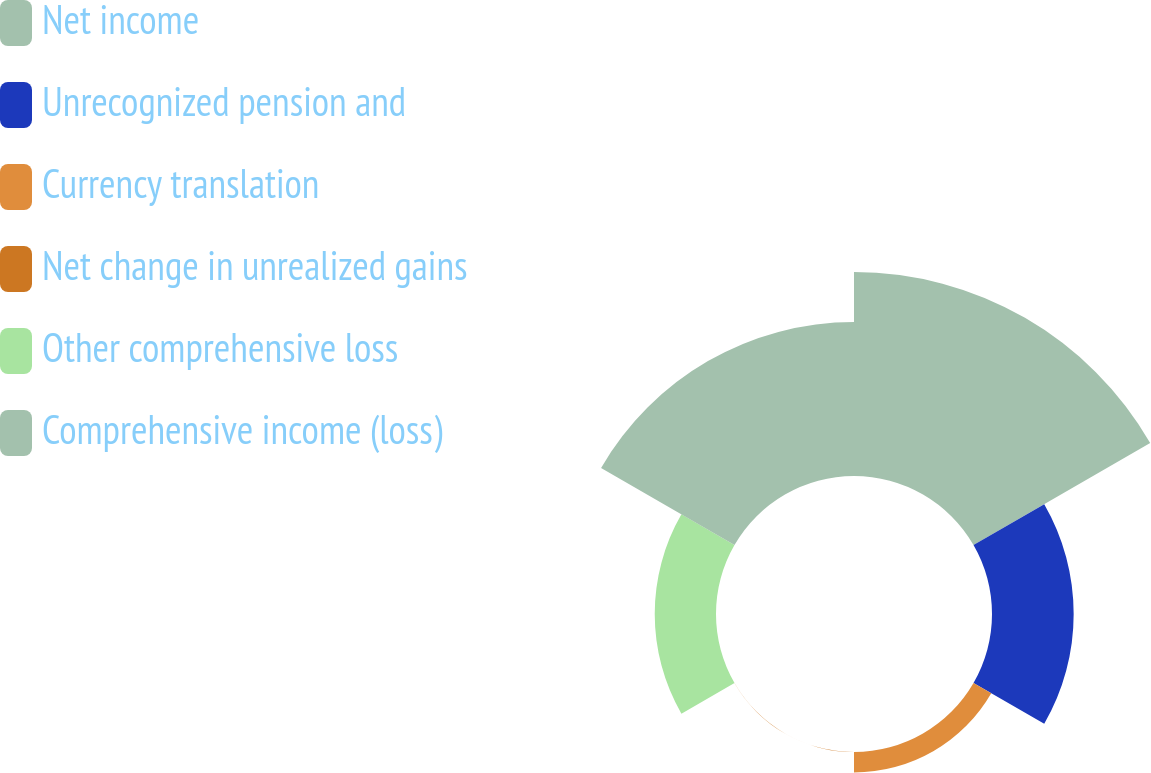Convert chart to OTSL. <chart><loc_0><loc_0><loc_500><loc_500><pie_chart><fcel>Net income<fcel>Unrecognized pension and<fcel>Currency translation<fcel>Net change in unrealized gains<fcel>Other comprehensive loss<fcel>Comprehensive income (loss)<nl><fcel>39.12%<fcel>15.66%<fcel>3.93%<fcel>0.02%<fcel>11.75%<fcel>29.54%<nl></chart> 